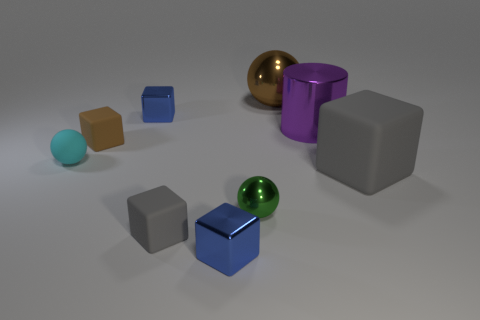Subtract all tiny spheres. How many spheres are left? 1 Subtract all cubes. How many objects are left? 4 Subtract all brown blocks. How many blocks are left? 4 Subtract all brown matte objects. Subtract all large brown things. How many objects are left? 7 Add 4 purple shiny cylinders. How many purple shiny cylinders are left? 5 Add 3 small shiny balls. How many small shiny balls exist? 4 Add 1 big spheres. How many objects exist? 10 Subtract 0 yellow balls. How many objects are left? 9 Subtract 3 blocks. How many blocks are left? 2 Subtract all cyan blocks. Subtract all yellow balls. How many blocks are left? 5 